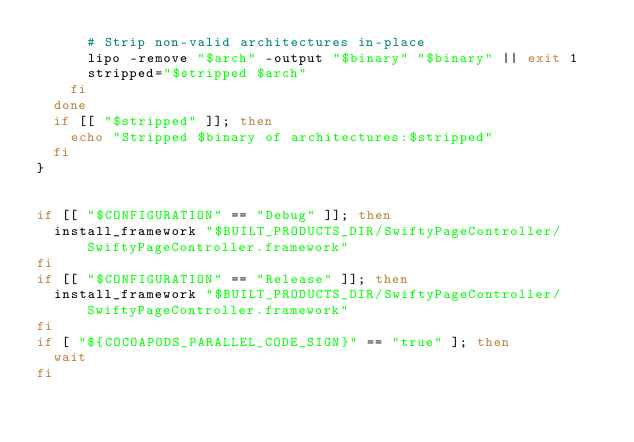Convert code to text. <code><loc_0><loc_0><loc_500><loc_500><_Bash_>      # Strip non-valid architectures in-place
      lipo -remove "$arch" -output "$binary" "$binary" || exit 1
      stripped="$stripped $arch"
    fi
  done
  if [[ "$stripped" ]]; then
    echo "Stripped $binary of architectures:$stripped"
  fi
}


if [[ "$CONFIGURATION" == "Debug" ]]; then
  install_framework "$BUILT_PRODUCTS_DIR/SwiftyPageController/SwiftyPageController.framework"
fi
if [[ "$CONFIGURATION" == "Release" ]]; then
  install_framework "$BUILT_PRODUCTS_DIR/SwiftyPageController/SwiftyPageController.framework"
fi
if [ "${COCOAPODS_PARALLEL_CODE_SIGN}" == "true" ]; then
  wait
fi
</code> 